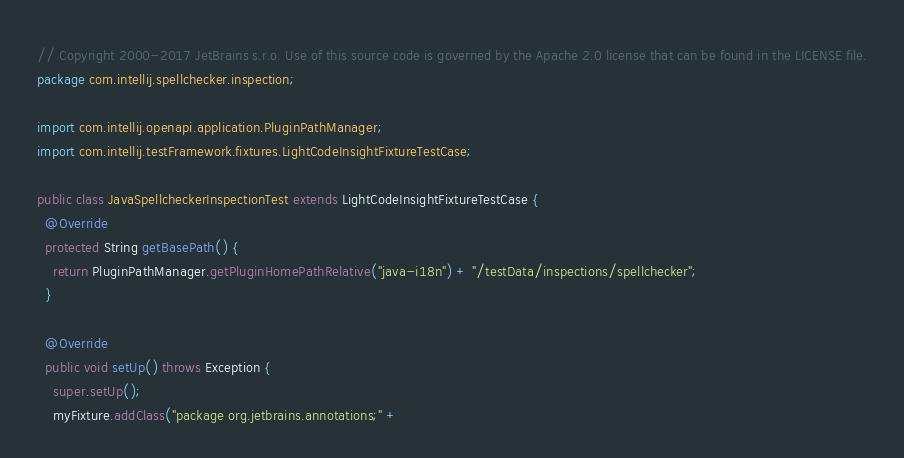<code> <loc_0><loc_0><loc_500><loc_500><_Java_>// Copyright 2000-2017 JetBrains s.r.o. Use of this source code is governed by the Apache 2.0 license that can be found in the LICENSE file.
package com.intellij.spellchecker.inspection;

import com.intellij.openapi.application.PluginPathManager;
import com.intellij.testFramework.fixtures.LightCodeInsightFixtureTestCase;

public class JavaSpellcheckerInspectionTest extends LightCodeInsightFixtureTestCase {
  @Override
  protected String getBasePath() {
    return PluginPathManager.getPluginHomePathRelative("java-i18n") + "/testData/inspections/spellchecker";
  }

  @Override
  public void setUp() throws Exception {
    super.setUp();
    myFixture.addClass("package org.jetbrains.annotations;" +</code> 